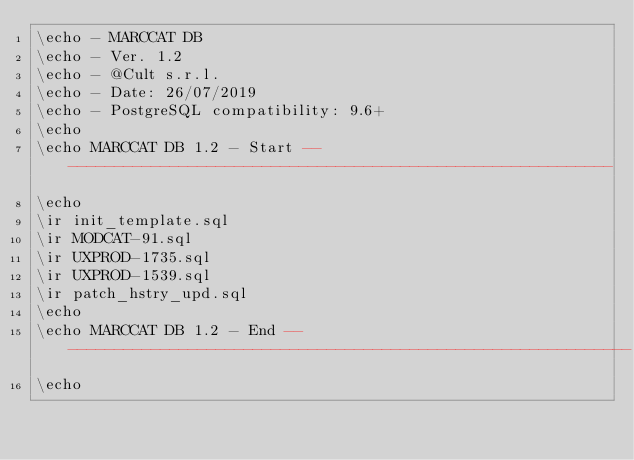Convert code to text. <code><loc_0><loc_0><loc_500><loc_500><_SQL_>\echo - MARCCAT DB
\echo - Ver. 1.2
\echo - @Cult s.r.l.
\echo - Date: 26/07/2019
\echo - PostgreSQL compatibility: 9.6+
\echo
\echo MARCCAT DB 1.2 - Start -------------------------------------------------------------
\echo
\ir init_template.sql
\ir MODCAT-91.sql
\ir UXPROD-1735.sql
\ir UXPROD-1539.sql
\ir patch_hstry_upd.sql
\echo
\echo MARCCAT DB 1.2 - End ---------------------------------------------------------------
\echo
</code> 